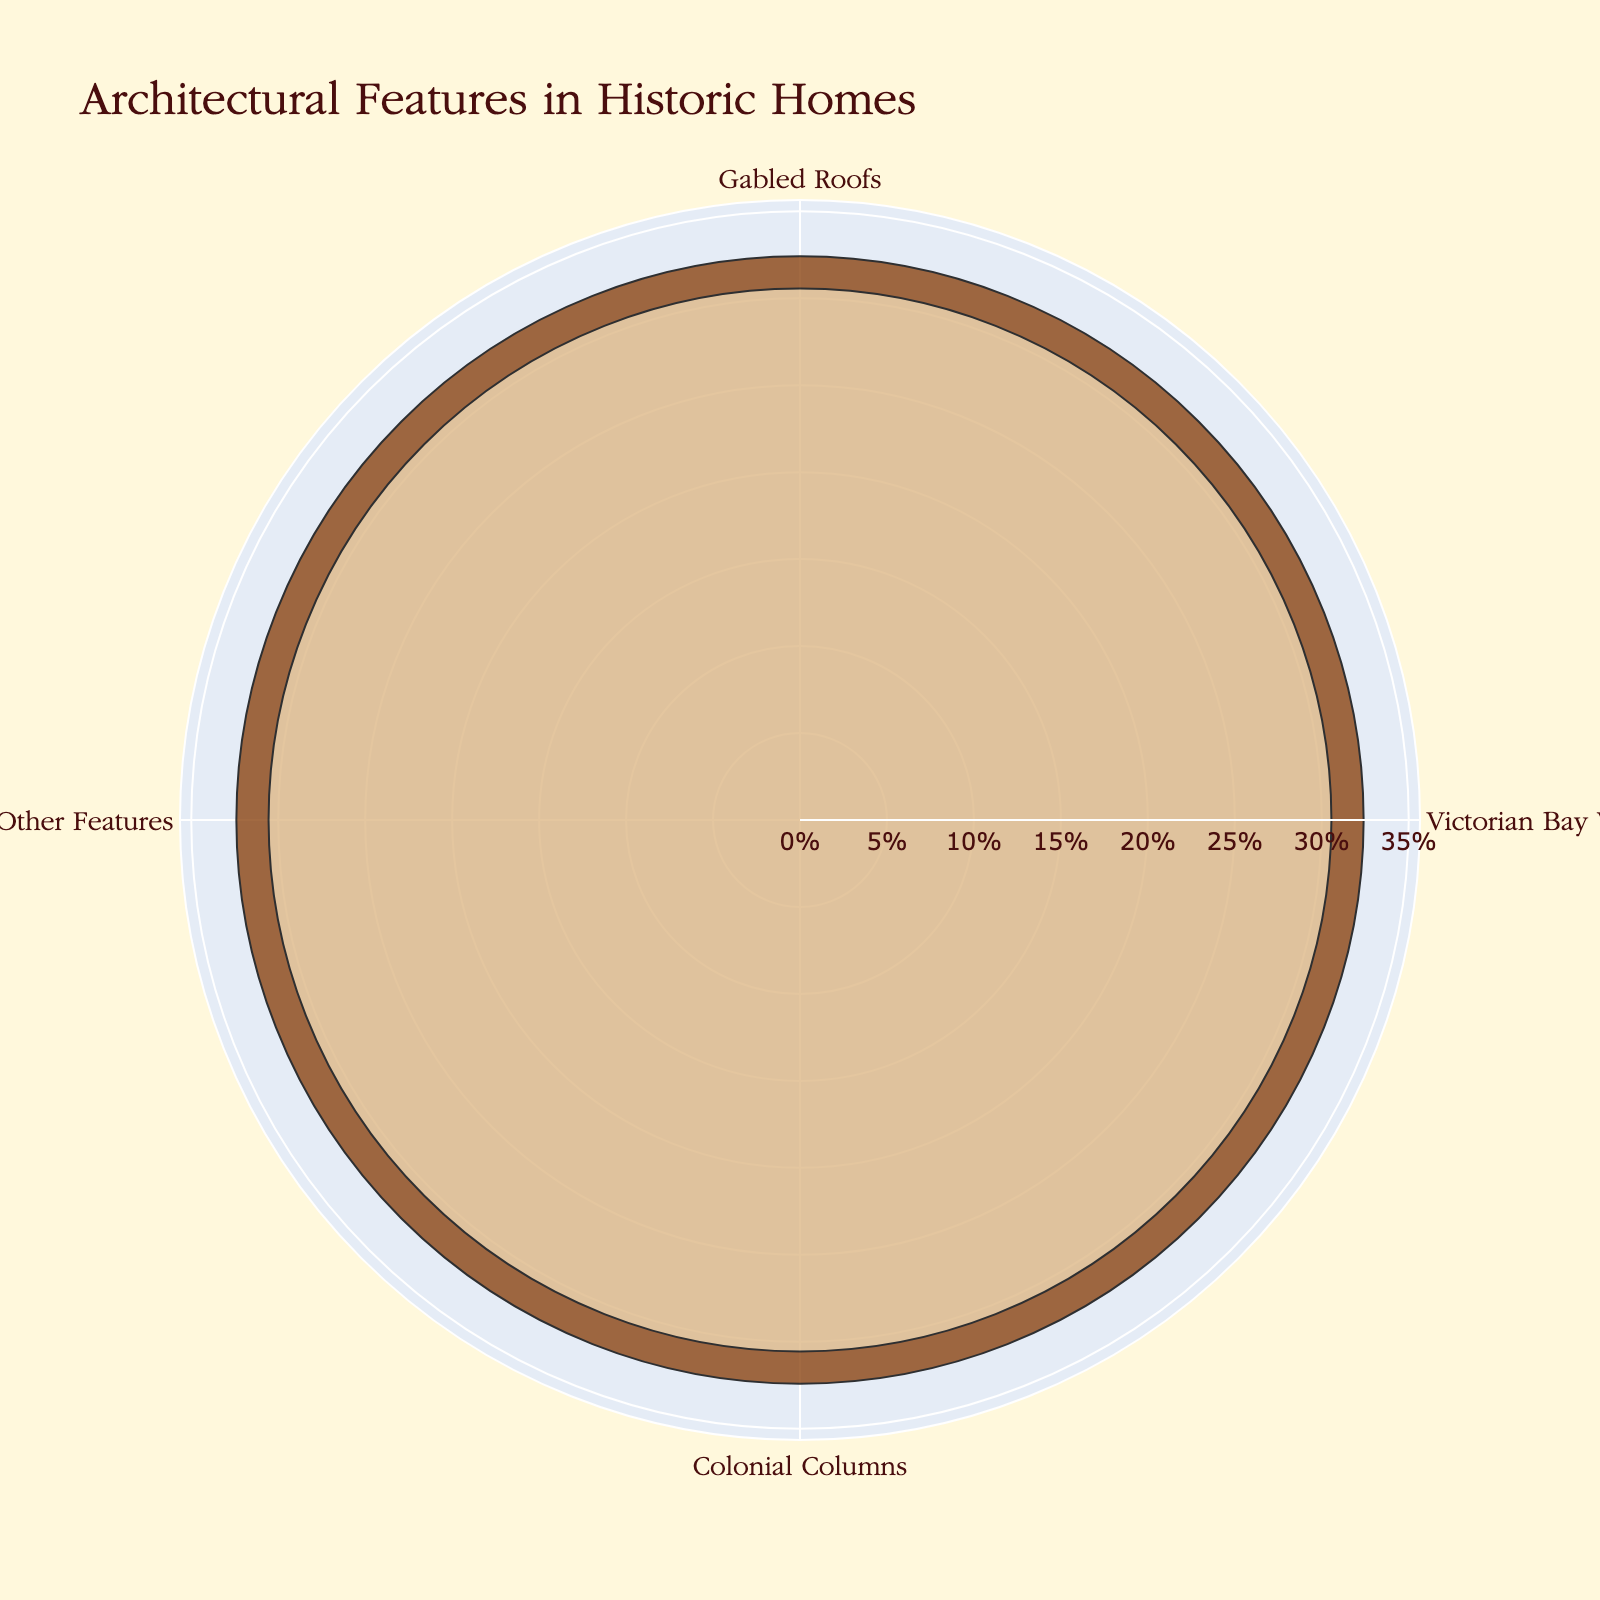What is the title of the rose chart? The title is usually found at the top of the figure and provides a summary of the main topic or data being displayed.
Answer: Architectural Features in Historic Homes What color is used to represent the feature with the highest count? The feature with the highest count is visually noticeable in the chart and its associated color can be identified easily.
Answer: Brown (#8B4513) What percentage of historic homes have Gabled Roofs? To find this, look at the segment representing Gabled Roofs and locate the percentage label close to it.
Answer: 35.0% How many features are combined under 'Other Features'? The 'Other Features' segment combines all features not in the top 3. Noting down the features from the data that are not part of the top 3 helps.
Answer: 3 features (Tudor Timbering, Queen Anne Turrets, and Mansard Roofs) Which feature is least common among the top 3 architectural features? Among the top 3 features (Gabled Roofs, Victorian Bay Windows, Colonial Columns), identify the one with the smallest percentage.
Answer: Colonial Columns What's the combined percentage of Victorian Bay Windows and Colonial Columns? Sum the percentages of Victorian Bay Windows and Colonial Columns.
Answer: Victorian Bay Windows (22%) + Colonial Columns (18%) = 40% How does the count for 'Other Features' compare to the count for Colonial Columns? Compare the individual counts of 'Other Features' and Colonial Columns.
Answer: Other Features (33) is higher than Colonial Columns (18) What feature represents the second most common architectural element in historic homes? Identify the feature with the second highest percentage on the chart.
Answer: Victorian Bay Windows Why might the rose chart use a radial (polar) plot instead of a bar chart? Rose charts are often used to show data where the length represents frequency and can circularly compare categories. This format emphasizes the cyclical nature and importance of each category equally.
Answer: To emphasize cyclical nature and create a visual impact How much more common are Gabled Roofs than Victorian Bay Windows? Subtract the count of Victorian Bay Windows from the count of Gabled Roofs.
Answer: 35 - 22 = 13 